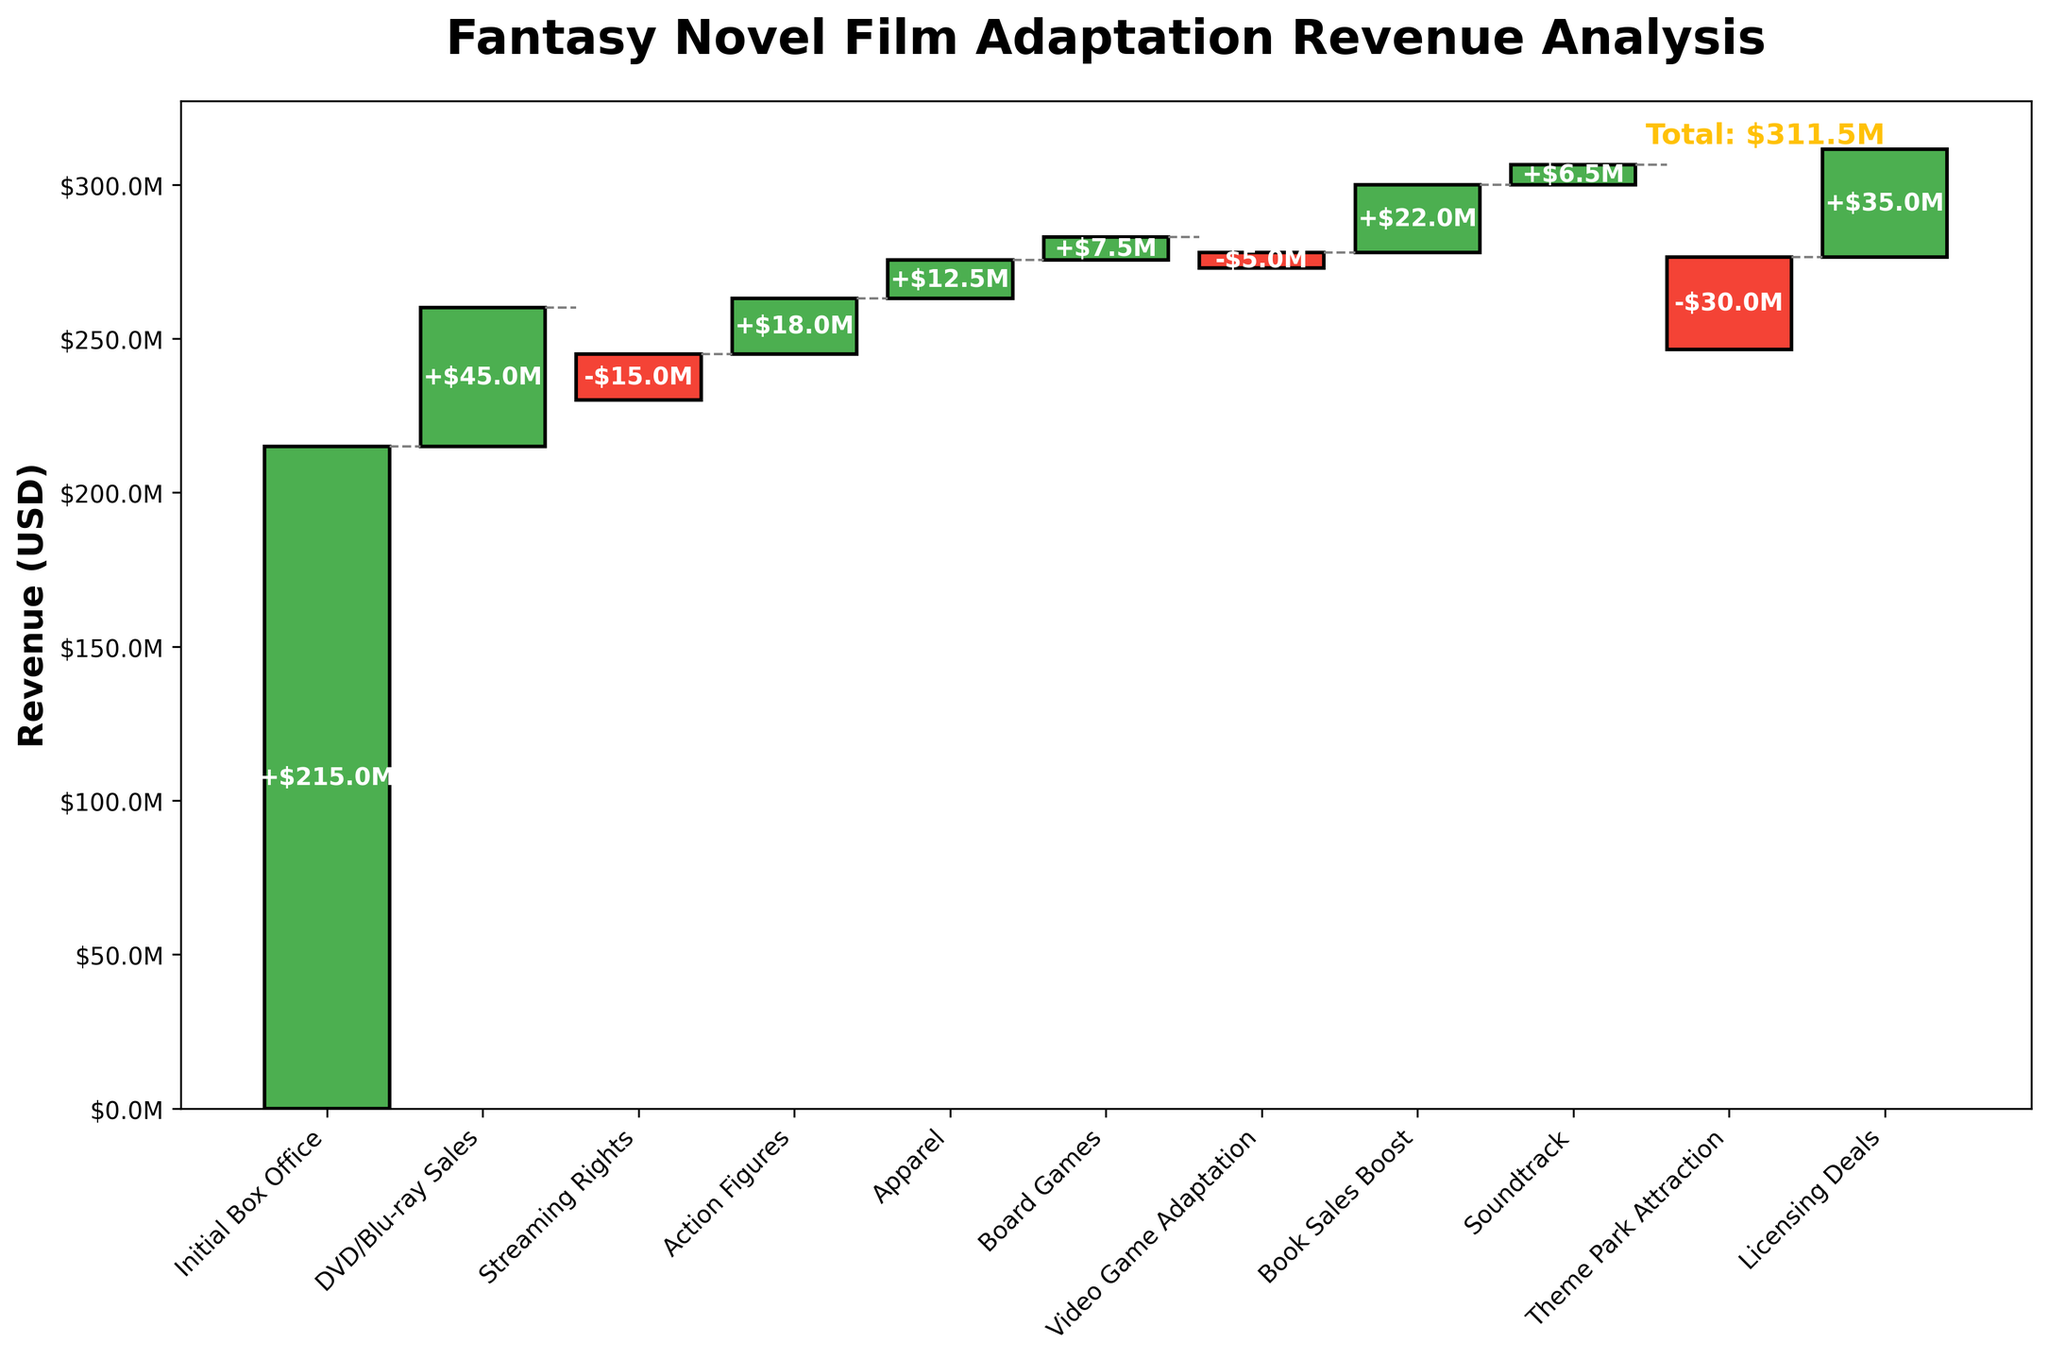What's the title of the chart? The title is prominently displayed at the top center of the chart. By observing the chart, we see that it reads "Fantasy Novel Film Adaptation Revenue Analysis."
Answer: Fantasy Novel Film Adaptation Revenue Analysis What color indicates a positive revenue contribution? In the chart, positive contributions are represented by green-colored bars. These bars are easily identifiable as they contrast with the red-colored negative revenue contributions.
Answer: Green Which category has the highest negative revenue impact? To find the category with the highest negative impact, we look for the largest red bar. The "Theme Park Attraction" category stands out as it has the largest red bar, indicating the highest negative revenue impact.
Answer: Theme Park Attraction How much revenue did DVD/Blu-ray Sales contribute? To determine the revenue contribution from DVD/Blu-ray Sales, we examine the green bar labeled "DVD/Blu-ray Sales." The height of this bar signifies a contribution of $45 million.
Answer: $45 million What is the combined revenue impact of "Streaming Rights" and "Video Game Adaptation"? To find the combined impact, add the values of "Streaming Rights" (-$15 million) and "Video Game Adaptation" (-$5 million). This results in a total combined impact of -$20 million.
Answer: -$20 million Which category generates the highest positive revenue after Initial Box Office? After Initial Box Office, we look for the tallest green bar to identify the highest positive revenue contributor. The category "Licensing Deals" stands out with a contribution of $35 million.
Answer: Licensing Deals What is the overall trend of the categories contributing to revenue after "Action Figures"? Observing the bars after "Action Figures," we see alternating positive and negative contributions. Notably, "Apparel" and "Book Sales Boost" are positive contributors, while "Video Game Adaptation" and "Theme Park Attraction" are negative. This indicates a mixed but generally downward trend in certain areas.
Answer: Mixed but generally downward How much more revenue did "Licensing Deals" generate compared to "Board Games"? To find this, subtract the revenue from "Board Games" ($7.5 million) from "Licensing Deals" ($35 million). This equals $27.5 million.
Answer: $27.5 million What is the total revenue achieved, as marked on the chart? To find the total revenue, look at the text indicated at the end of the waterfall chart, which states "Total: $311.5M."
Answer: $311.5 million 